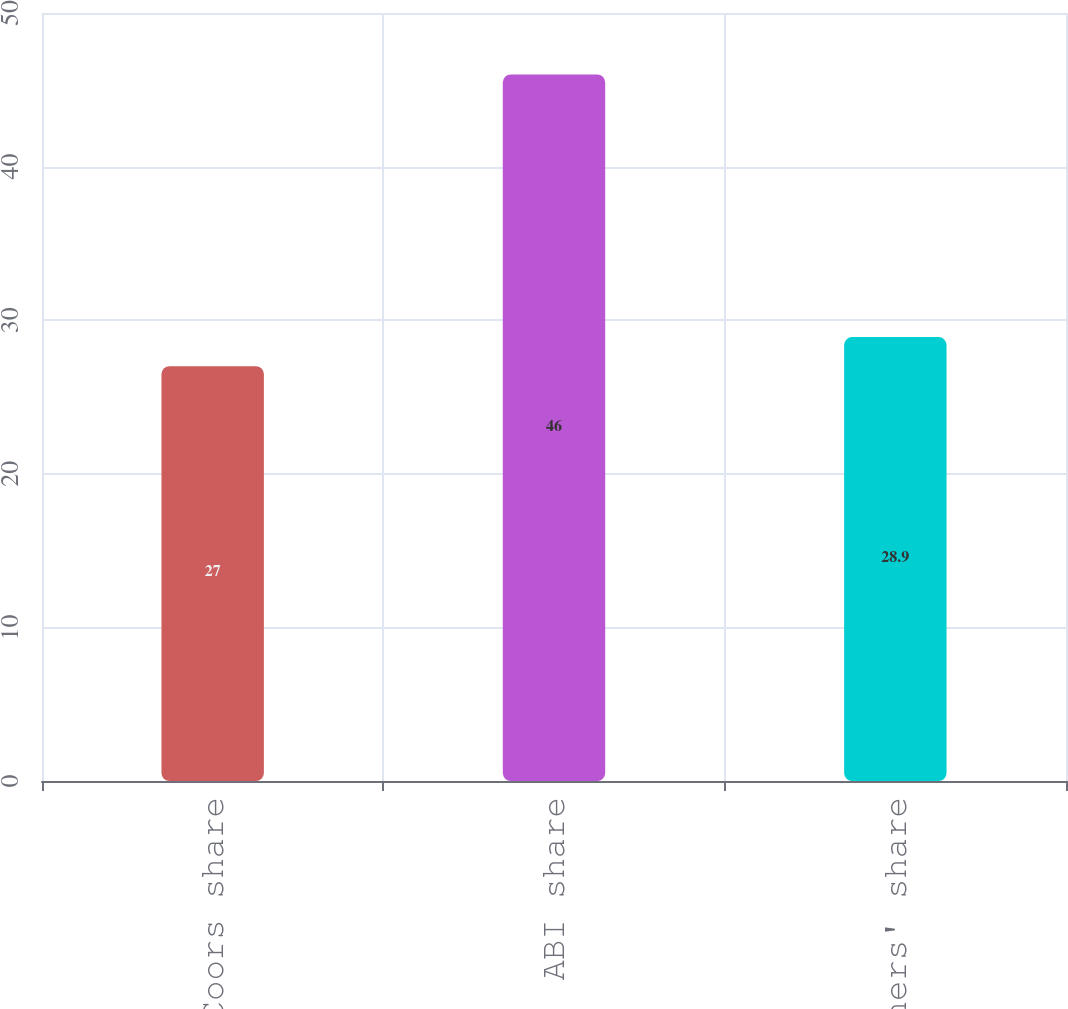Convert chart to OTSL. <chart><loc_0><loc_0><loc_500><loc_500><bar_chart><fcel>MillerCoors share<fcel>ABI share<fcel>Others' share<nl><fcel>27<fcel>46<fcel>28.9<nl></chart> 